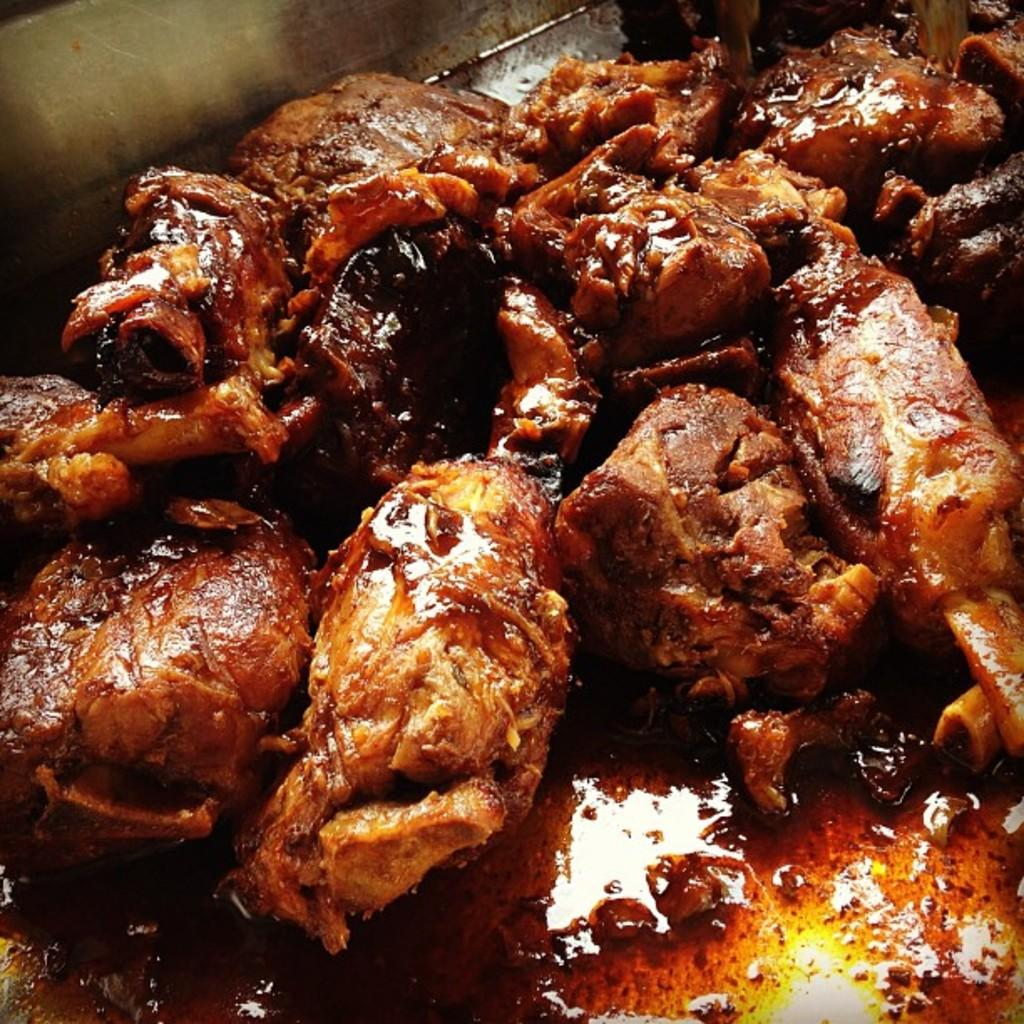What is present in the container in the image? There is food in a container in the image. What type of mint is growing in the container in the image? There is no mint present in the image; it contains food. How much debt is associated with the container in the image? There is no mention of debt in the image, as it only shows a container with food. 